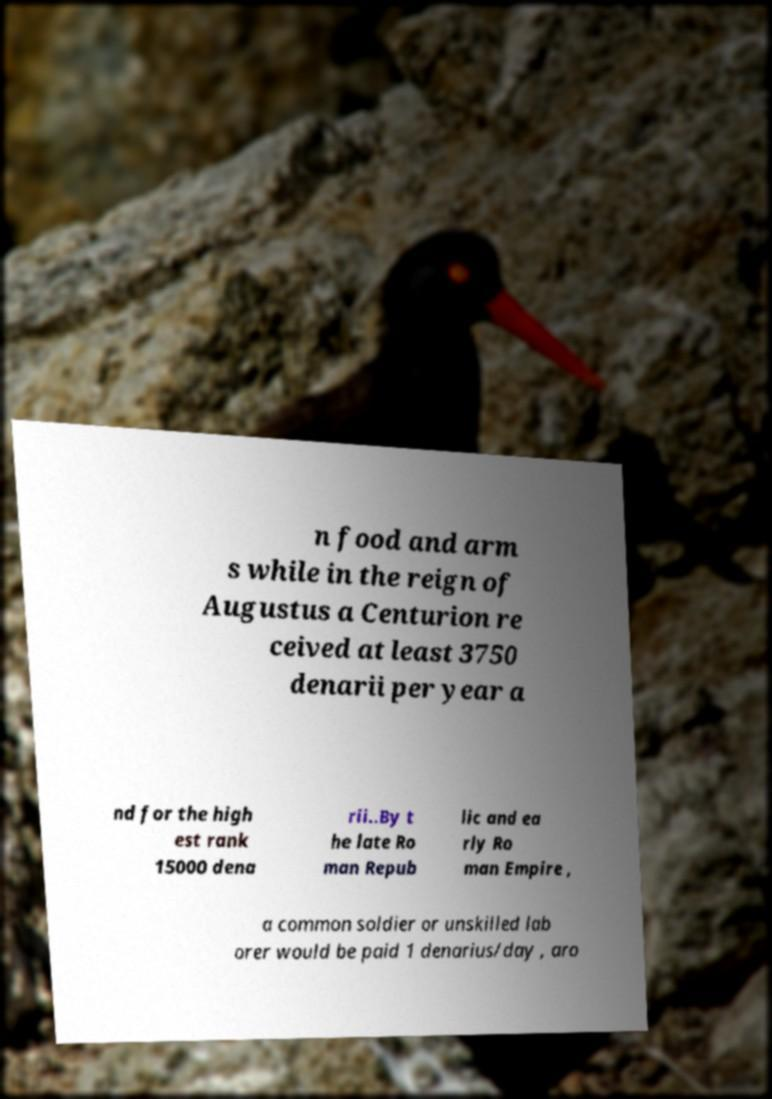What messages or text are displayed in this image? I need them in a readable, typed format. n food and arm s while in the reign of Augustus a Centurion re ceived at least 3750 denarii per year a nd for the high est rank 15000 dena rii..By t he late Ro man Repub lic and ea rly Ro man Empire , a common soldier or unskilled lab orer would be paid 1 denarius/day , aro 